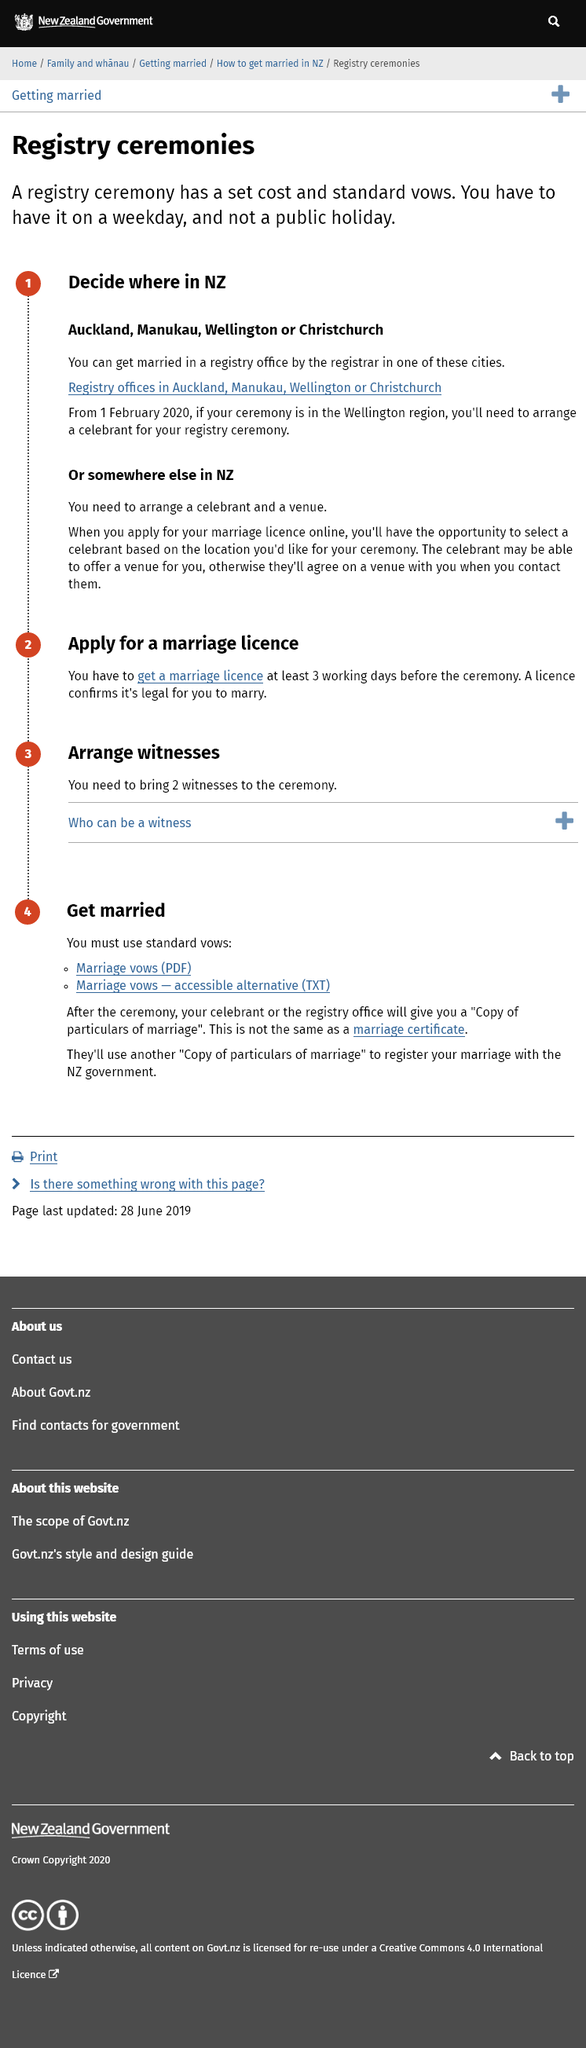Draw attention to some important aspects in this diagram. It is necessary to obtain a marriage license at least three working days prior to the ceremony. You can get married in a registry office in Auckland, Manukau, Wellington, or Christchurch in New Zealand. If you wish to marry in Wellington after 1 February 2020, it is necessary to secure the services of a celebrant for a ceremony within the Wellington region. 